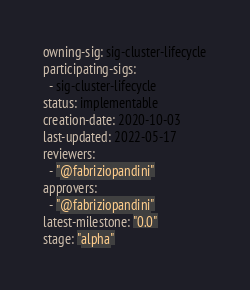<code> <loc_0><loc_0><loc_500><loc_500><_YAML_>owning-sig: sig-cluster-lifecycle
participating-sigs:
  - sig-cluster-lifecycle
status: implementable
creation-date: 2020-10-03
last-updated: 2022-05-17
reviewers:
  - "@fabriziopandini"
approvers:
  - "@fabriziopandini"
latest-milestone: "0.0"
stage: "alpha"
</code> 